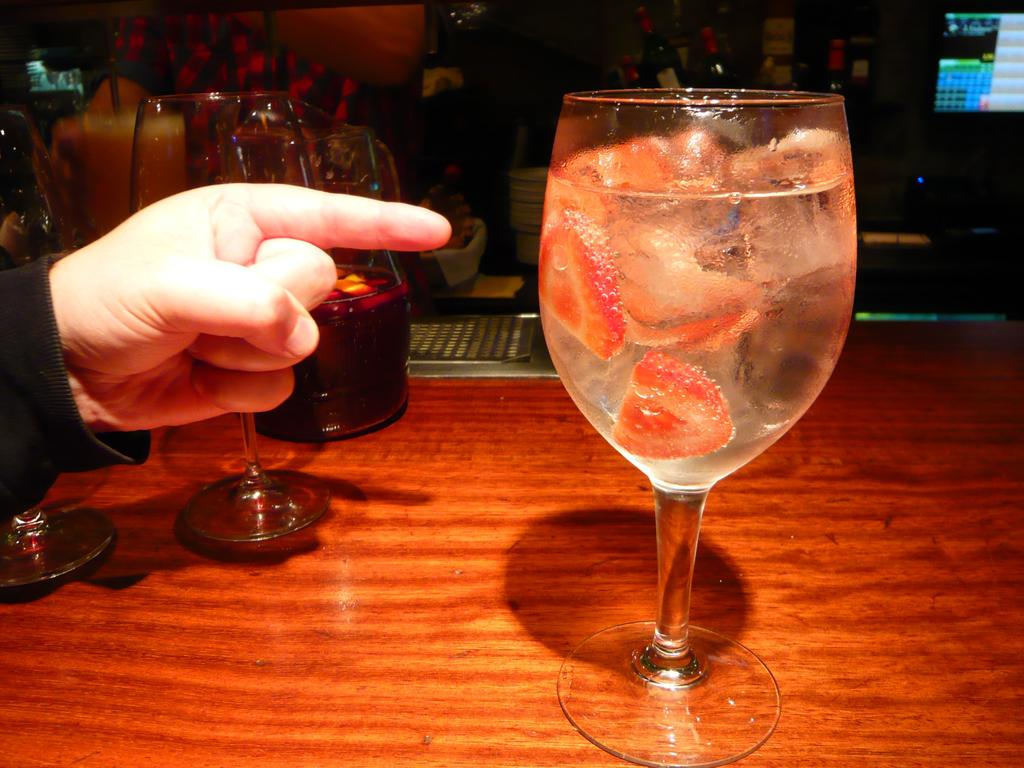What is in the glass that is visible in the image? There is a glass with a drink in the image. What can be found inside the drink in the glass? The drink contains strawberry slices and ice cubes. What is in the other glass in the image? There is another glass with wine in the image. Whose hand is near the glass with wine? A person's hand is near the glass with wine. How many jellyfish are swimming in the glass with the drink? There are no jellyfish present in the image; the drink contains strawberry slices and ice cubes. What type of boot is visible in the image? There is no boot present in the image. 